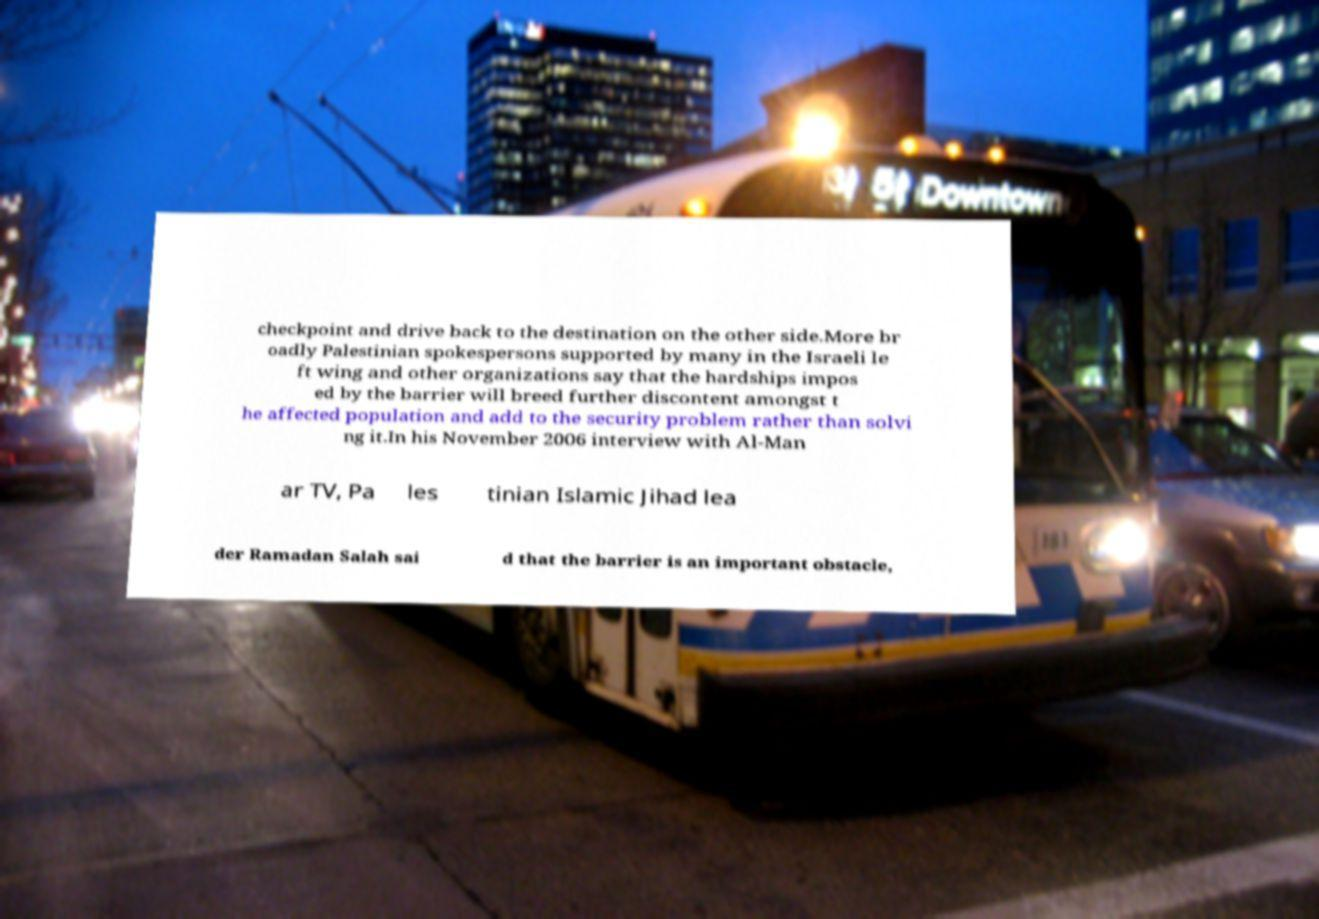I need the written content from this picture converted into text. Can you do that? checkpoint and drive back to the destination on the other side.More br oadly Palestinian spokespersons supported by many in the Israeli le ft wing and other organizations say that the hardships impos ed by the barrier will breed further discontent amongst t he affected population and add to the security problem rather than solvi ng it.In his November 2006 interview with Al-Man ar TV, Pa les tinian Islamic Jihad lea der Ramadan Salah sai d that the barrier is an important obstacle, 